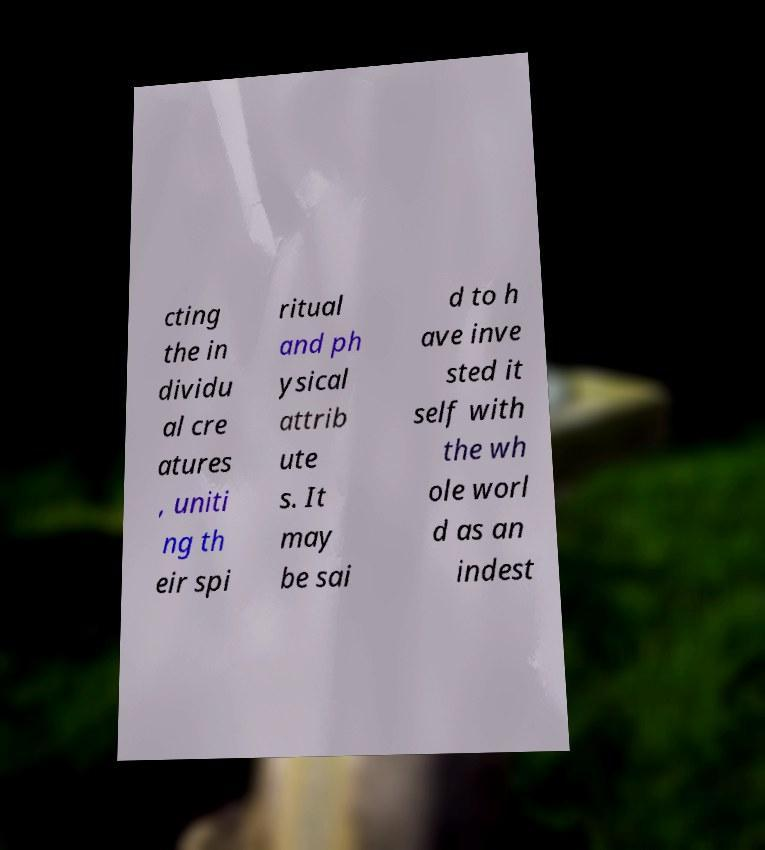Can you accurately transcribe the text from the provided image for me? cting the in dividu al cre atures , uniti ng th eir spi ritual and ph ysical attrib ute s. It may be sai d to h ave inve sted it self with the wh ole worl d as an indest 